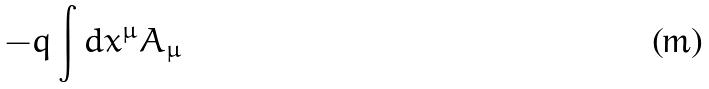<formula> <loc_0><loc_0><loc_500><loc_500>- q \int d x ^ { \mu } A _ { \mu }</formula> 